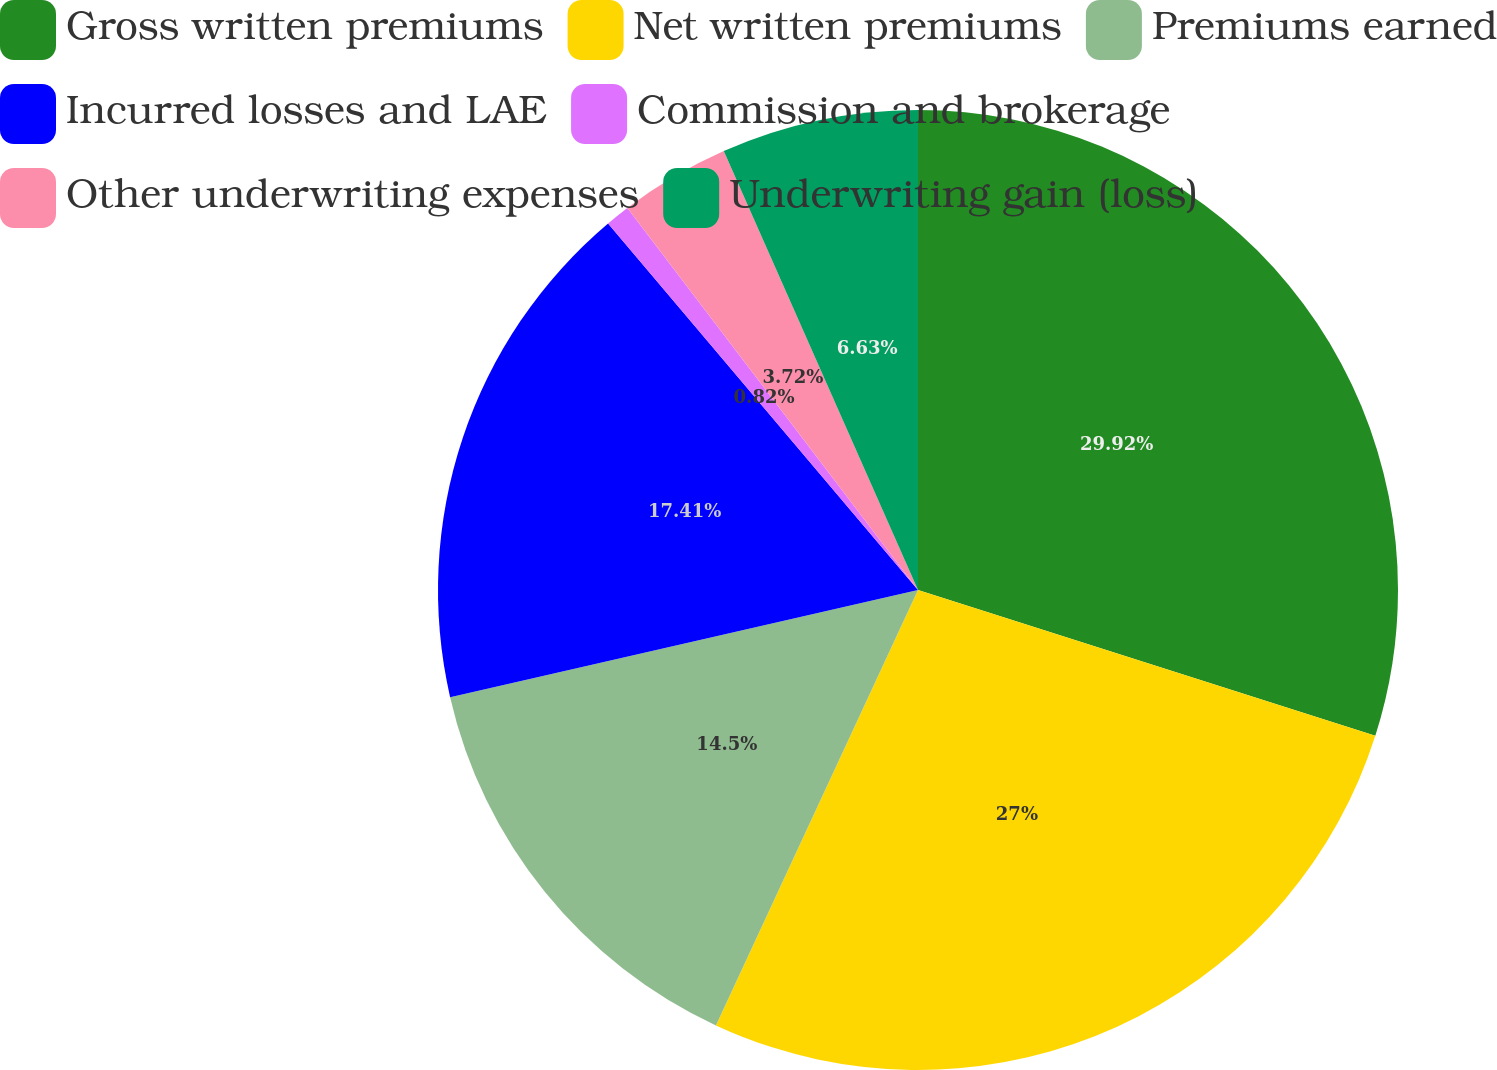<chart> <loc_0><loc_0><loc_500><loc_500><pie_chart><fcel>Gross written premiums<fcel>Net written premiums<fcel>Premiums earned<fcel>Incurred losses and LAE<fcel>Commission and brokerage<fcel>Other underwriting expenses<fcel>Underwriting gain (loss)<nl><fcel>29.91%<fcel>27.0%<fcel>14.5%<fcel>17.41%<fcel>0.82%<fcel>3.72%<fcel>6.63%<nl></chart> 